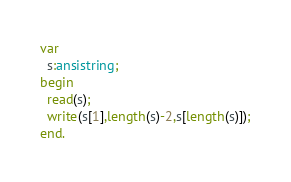Convert code to text. <code><loc_0><loc_0><loc_500><loc_500><_Pascal_>var
  s:ansistring;
begin
  read(s);
  write(s[1],length(s)-2,s[length(s)]);
end.</code> 